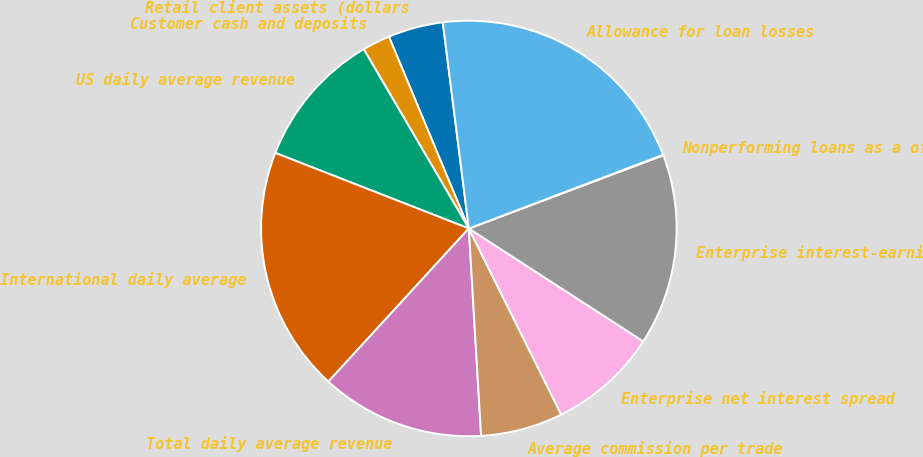Convert chart to OTSL. <chart><loc_0><loc_0><loc_500><loc_500><pie_chart><fcel>Retail client assets (dollars<fcel>Customer cash and deposits<fcel>US daily average revenue<fcel>International daily average<fcel>Total daily average revenue<fcel>Average commission per trade<fcel>Enterprise net interest spread<fcel>Enterprise interest-earning<fcel>Nonperforming loans as a of<fcel>Allowance for loan losses<nl><fcel>4.28%<fcel>2.16%<fcel>10.64%<fcel>19.12%<fcel>12.76%<fcel>6.4%<fcel>8.52%<fcel>14.88%<fcel>0.04%<fcel>21.24%<nl></chart> 